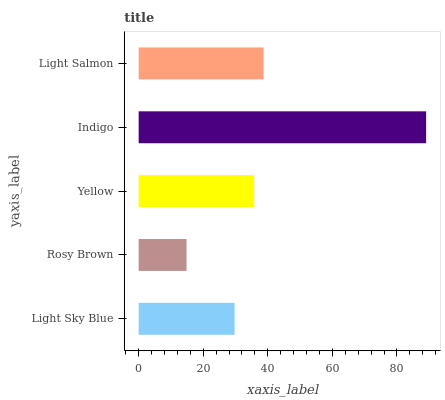Is Rosy Brown the minimum?
Answer yes or no. Yes. Is Indigo the maximum?
Answer yes or no. Yes. Is Yellow the minimum?
Answer yes or no. No. Is Yellow the maximum?
Answer yes or no. No. Is Yellow greater than Rosy Brown?
Answer yes or no. Yes. Is Rosy Brown less than Yellow?
Answer yes or no. Yes. Is Rosy Brown greater than Yellow?
Answer yes or no. No. Is Yellow less than Rosy Brown?
Answer yes or no. No. Is Yellow the high median?
Answer yes or no. Yes. Is Yellow the low median?
Answer yes or no. Yes. Is Light Sky Blue the high median?
Answer yes or no. No. Is Light Salmon the low median?
Answer yes or no. No. 